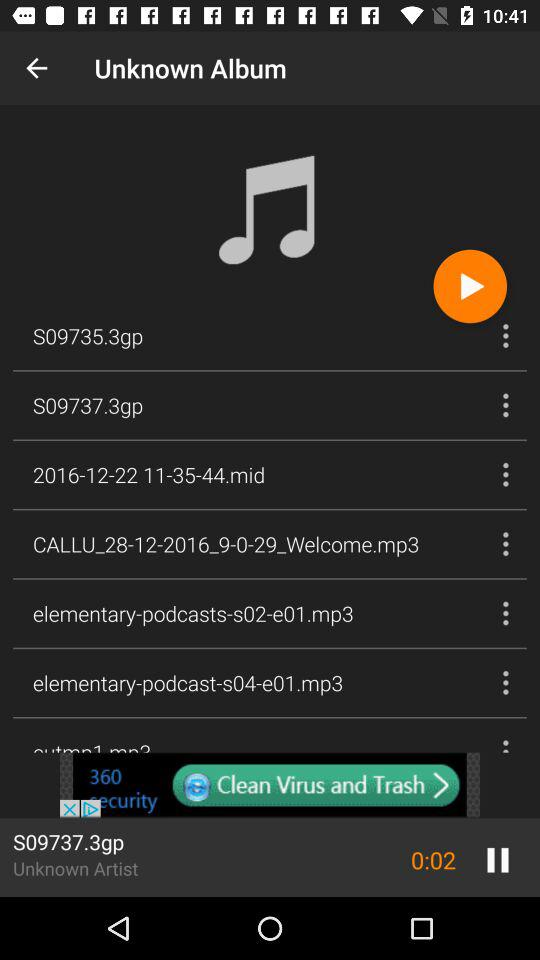What is the duration of the song "S09737.3gp"? The duration is 2 seconds. 